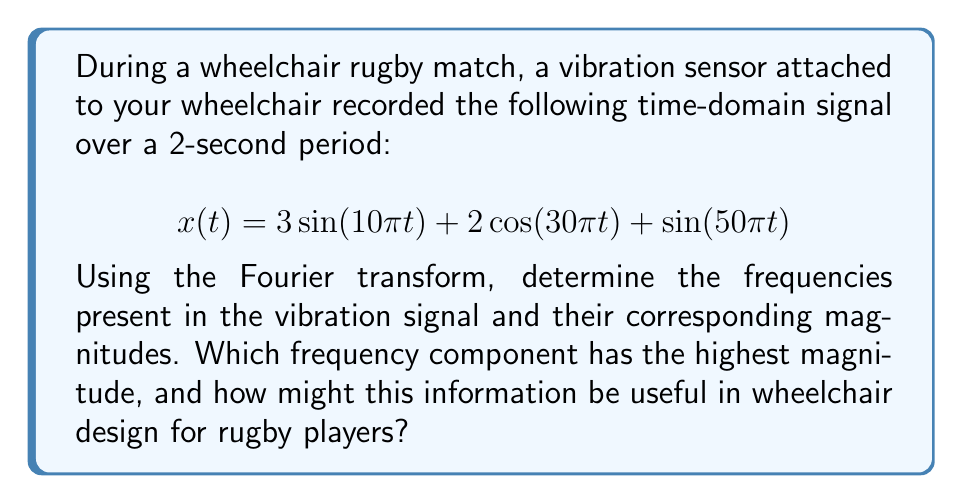Could you help me with this problem? To analyze the frequency components of the vibration signal, we need to apply the Fourier transform. The given signal is already expressed as a sum of sinusoids, which makes our analysis straightforward.

1. Identify the frequencies:
   - $\sin(10\pi t)$ has a frequency of $f_1 = 5$ Hz
   - $\cos(30\pi t)$ has a frequency of $f_2 = 15$ Hz
   - $\sin(50\pi t)$ has a frequency of $f_3 = 25$ Hz

2. Determine the magnitudes:
   - For $\sin(10\pi t)$, the magnitude is $A_1 = 3$
   - For $\cos(30\pi t)$, the magnitude is $A_2 = 2$
   - For $\sin(50\pi t)$, the magnitude is $A_3 = 1$

3. The frequency component with the highest magnitude:
   The 5 Hz component has the highest magnitude of 3.

4. Usefulness in wheelchair design:
   Knowing the dominant frequency (5 Hz) and its magnitude can help engineers design wheelchairs that minimize vibrations at this frequency. This could involve:
   - Selecting materials or structures that dampen vibrations around 5 Hz
   - Designing suspension systems that specifically target this frequency
   - Adjusting wheel size or tire pressure to reduce vibrations at 5 Hz

By addressing the dominant frequency, wheelchair designers can improve comfort and performance for rugby players, potentially reducing fatigue and enhancing control during matches.
Answer: The vibration signal contains three frequency components:
1. 5 Hz with magnitude 3
2. 15 Hz with magnitude 2
3. 25 Hz with magnitude 1

The frequency component with the highest magnitude is 5 Hz. This information can be used to design wheelchairs with improved vibration dampening at 5 Hz, enhancing comfort and performance for rugby players. 